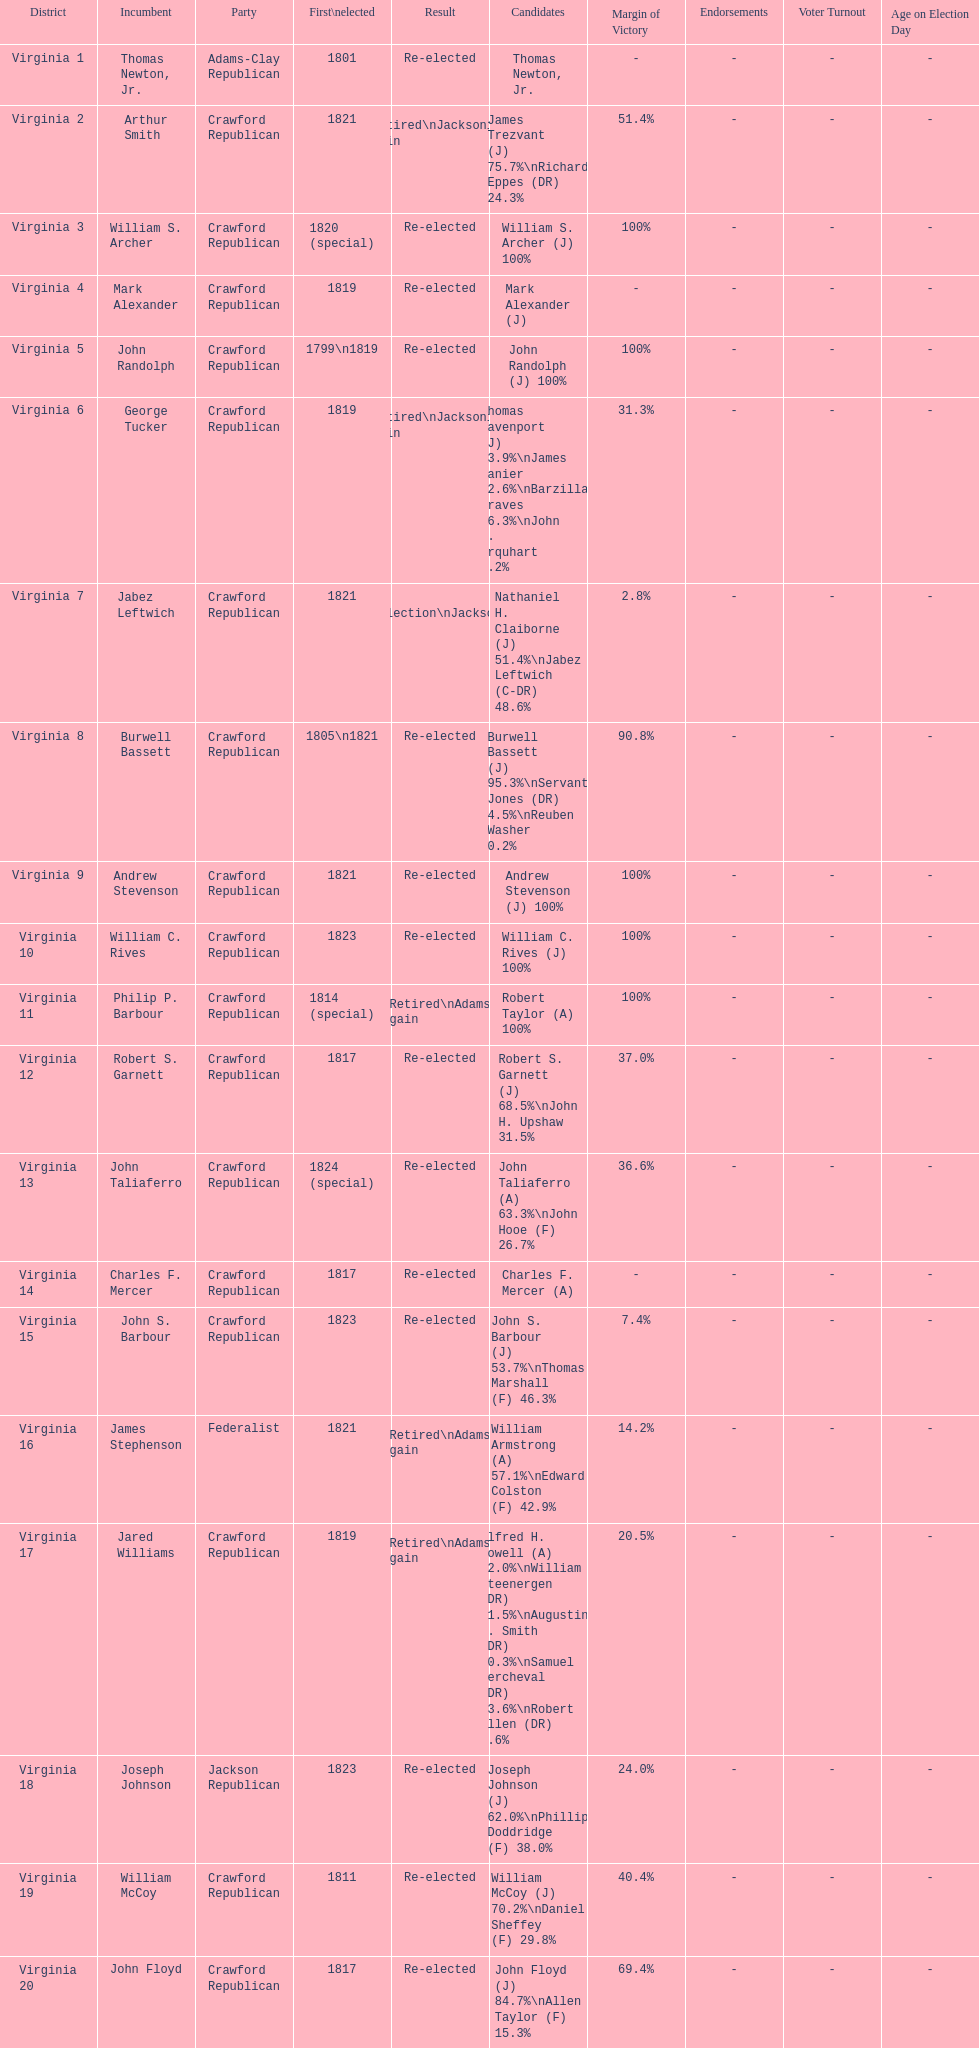Quantity of incumbents who retired or failed re-election 7. 